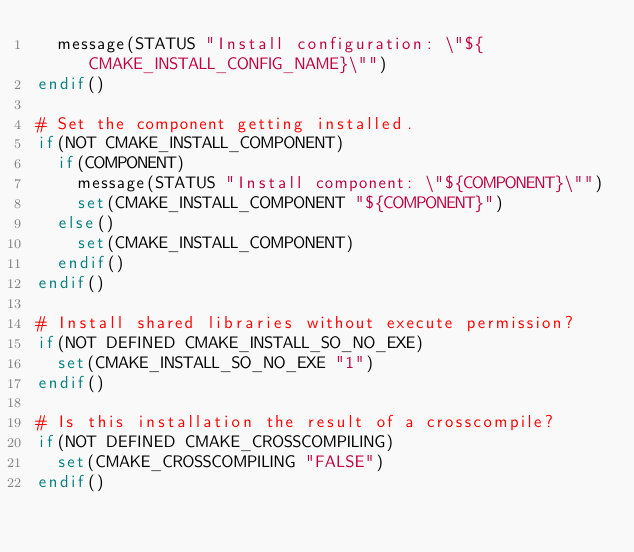Convert code to text. <code><loc_0><loc_0><loc_500><loc_500><_CMake_>  message(STATUS "Install configuration: \"${CMAKE_INSTALL_CONFIG_NAME}\"")
endif()

# Set the component getting installed.
if(NOT CMAKE_INSTALL_COMPONENT)
  if(COMPONENT)
    message(STATUS "Install component: \"${COMPONENT}\"")
    set(CMAKE_INSTALL_COMPONENT "${COMPONENT}")
  else()
    set(CMAKE_INSTALL_COMPONENT)
  endif()
endif()

# Install shared libraries without execute permission?
if(NOT DEFINED CMAKE_INSTALL_SO_NO_EXE)
  set(CMAKE_INSTALL_SO_NO_EXE "1")
endif()

# Is this installation the result of a crosscompile?
if(NOT DEFINED CMAKE_CROSSCOMPILING)
  set(CMAKE_CROSSCOMPILING "FALSE")
endif()

</code> 